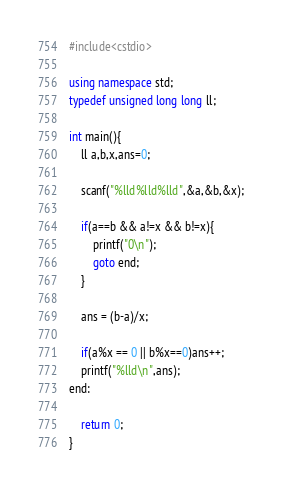Convert code to text. <code><loc_0><loc_0><loc_500><loc_500><_C++_>#include<cstdio>

using namespace std;
typedef unsigned long long ll;

int main(){
    ll a,b,x,ans=0;

    scanf("%lld%lld%lld",&a,&b,&x);

    if(a==b && a!=x && b!=x){
        printf("0\n");
        goto end;
    }

    ans = (b-a)/x;

    if(a%x == 0 || b%x==0)ans++; 
    printf("%lld\n",ans);
end:

    return 0;
}
</code> 